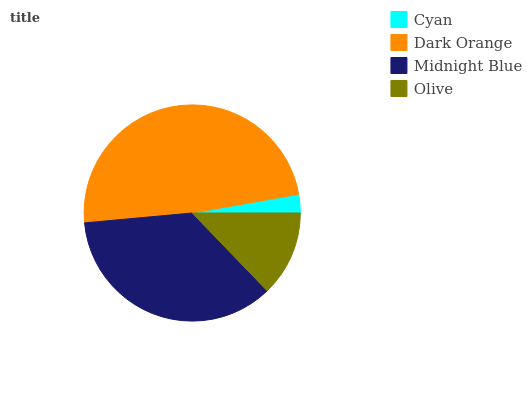Is Cyan the minimum?
Answer yes or no. Yes. Is Dark Orange the maximum?
Answer yes or no. Yes. Is Midnight Blue the minimum?
Answer yes or no. No. Is Midnight Blue the maximum?
Answer yes or no. No. Is Dark Orange greater than Midnight Blue?
Answer yes or no. Yes. Is Midnight Blue less than Dark Orange?
Answer yes or no. Yes. Is Midnight Blue greater than Dark Orange?
Answer yes or no. No. Is Dark Orange less than Midnight Blue?
Answer yes or no. No. Is Midnight Blue the high median?
Answer yes or no. Yes. Is Olive the low median?
Answer yes or no. Yes. Is Cyan the high median?
Answer yes or no. No. Is Dark Orange the low median?
Answer yes or no. No. 